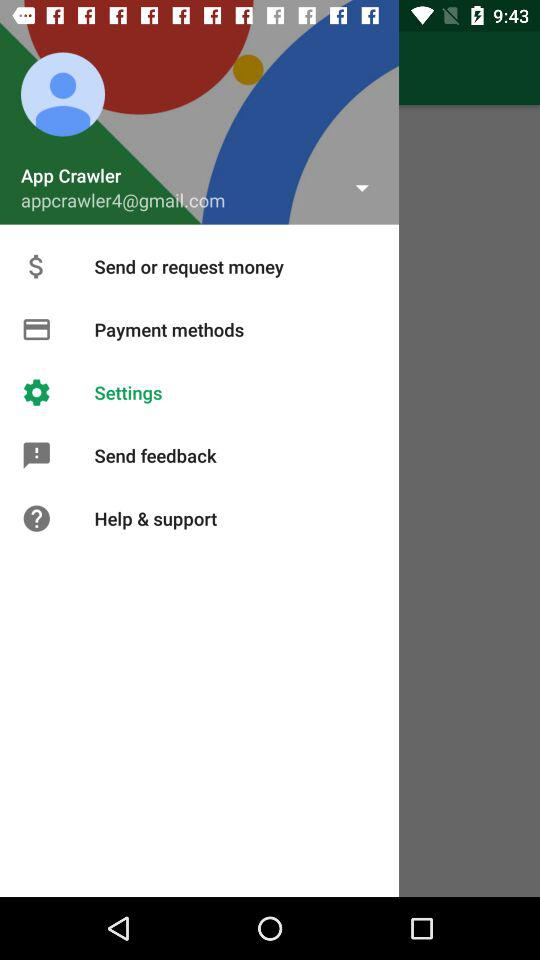Which option is selected in the menu? The selected option is "Settings". 